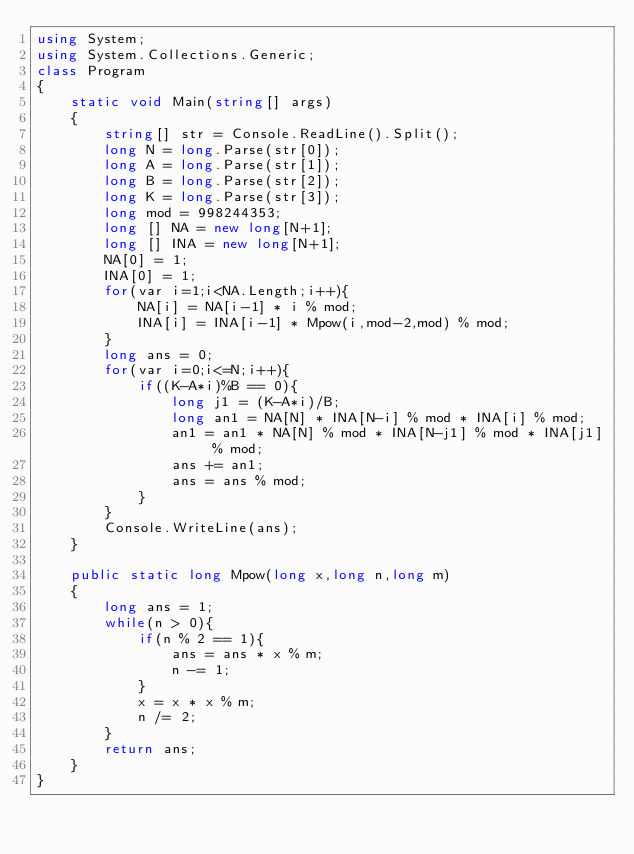<code> <loc_0><loc_0><loc_500><loc_500><_C#_>using System;
using System.Collections.Generic;
class Program
{
	static void Main(string[] args)
	{
		string[] str = Console.ReadLine().Split();
		long N = long.Parse(str[0]);
		long A = long.Parse(str[1]);
		long B = long.Parse(str[2]);
		long K = long.Parse(str[3]);
		long mod = 998244353;
		long [] NA = new long[N+1];
		long [] INA = new long[N+1];
		NA[0] = 1;
		INA[0] = 1;
		for(var i=1;i<NA.Length;i++){
			NA[i] = NA[i-1] * i % mod;
			INA[i] = INA[i-1] * Mpow(i,mod-2,mod) % mod;
		}
		long ans = 0;
		for(var i=0;i<=N;i++){
			if((K-A*i)%B == 0){
				long j1 = (K-A*i)/B;
				long an1 = NA[N] * INA[N-i] % mod * INA[i] % mod;
				an1 = an1 * NA[N] % mod * INA[N-j1] % mod * INA[j1] % mod;
				ans += an1;
				ans = ans % mod;
			}
		}
		Console.WriteLine(ans);
	}

	public static long Mpow(long x,long n,long m)
	{
		long ans = 1;
		while(n > 0){
			if(n % 2 == 1){
				ans = ans * x % m;
				n -= 1;
			}
			x = x * x % m;
			n /= 2;
		}
		return ans;
	}
}</code> 